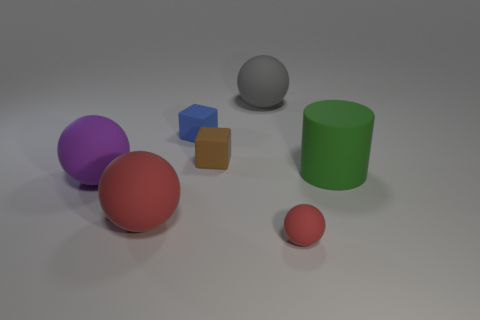Add 3 small cyan cylinders. How many objects exist? 10 Subtract all tiny red spheres. How many spheres are left? 3 Subtract all brown blocks. How many blocks are left? 1 Subtract all purple cylinders. How many red balls are left? 2 Subtract all balls. How many objects are left? 3 Subtract 1 cubes. How many cubes are left? 1 Subtract all yellow spheres. Subtract all yellow cylinders. How many spheres are left? 4 Subtract all tiny purple cylinders. Subtract all small blue rubber things. How many objects are left? 6 Add 2 gray objects. How many gray objects are left? 3 Add 6 large gray metallic things. How many large gray metallic things exist? 6 